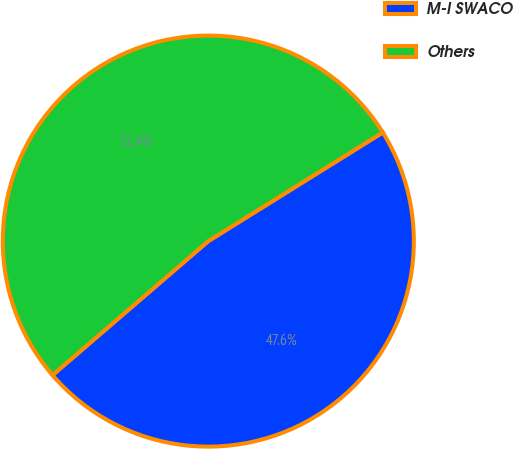Convert chart. <chart><loc_0><loc_0><loc_500><loc_500><pie_chart><fcel>M-I SWACO<fcel>Others<nl><fcel>47.56%<fcel>52.44%<nl></chart> 